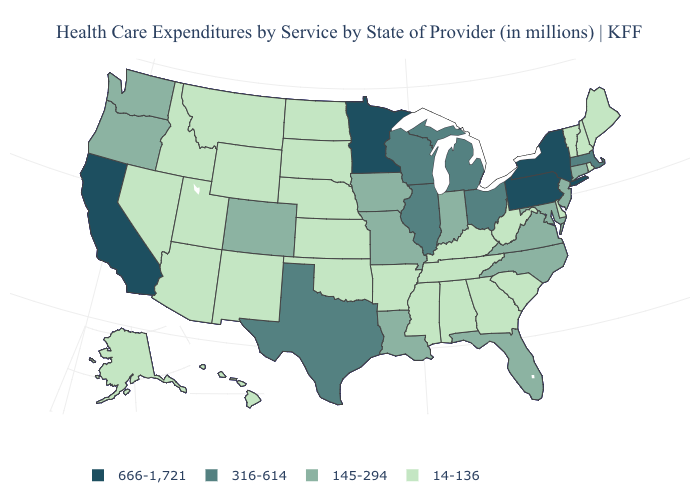Name the states that have a value in the range 145-294?
Concise answer only. Colorado, Connecticut, Florida, Indiana, Iowa, Louisiana, Maryland, Missouri, New Jersey, North Carolina, Oregon, Virginia, Washington. Name the states that have a value in the range 316-614?
Concise answer only. Illinois, Massachusetts, Michigan, Ohio, Texas, Wisconsin. Among the states that border New Mexico , which have the highest value?
Give a very brief answer. Texas. Does Florida have the highest value in the USA?
Quick response, please. No. Name the states that have a value in the range 14-136?
Concise answer only. Alabama, Alaska, Arizona, Arkansas, Delaware, Georgia, Hawaii, Idaho, Kansas, Kentucky, Maine, Mississippi, Montana, Nebraska, Nevada, New Hampshire, New Mexico, North Dakota, Oklahoma, Rhode Island, South Carolina, South Dakota, Tennessee, Utah, Vermont, West Virginia, Wyoming. Name the states that have a value in the range 14-136?
Quick response, please. Alabama, Alaska, Arizona, Arkansas, Delaware, Georgia, Hawaii, Idaho, Kansas, Kentucky, Maine, Mississippi, Montana, Nebraska, Nevada, New Hampshire, New Mexico, North Dakota, Oklahoma, Rhode Island, South Carolina, South Dakota, Tennessee, Utah, Vermont, West Virginia, Wyoming. How many symbols are there in the legend?
Concise answer only. 4. Is the legend a continuous bar?
Be succinct. No. What is the highest value in states that border Pennsylvania?
Answer briefly. 666-1,721. What is the highest value in states that border Washington?
Keep it brief. 145-294. Does Nebraska have the lowest value in the MidWest?
Be succinct. Yes. Name the states that have a value in the range 14-136?
Write a very short answer. Alabama, Alaska, Arizona, Arkansas, Delaware, Georgia, Hawaii, Idaho, Kansas, Kentucky, Maine, Mississippi, Montana, Nebraska, Nevada, New Hampshire, New Mexico, North Dakota, Oklahoma, Rhode Island, South Carolina, South Dakota, Tennessee, Utah, Vermont, West Virginia, Wyoming. What is the highest value in the USA?
Quick response, please. 666-1,721. Does North Carolina have the highest value in the USA?
Quick response, please. No. How many symbols are there in the legend?
Concise answer only. 4. 